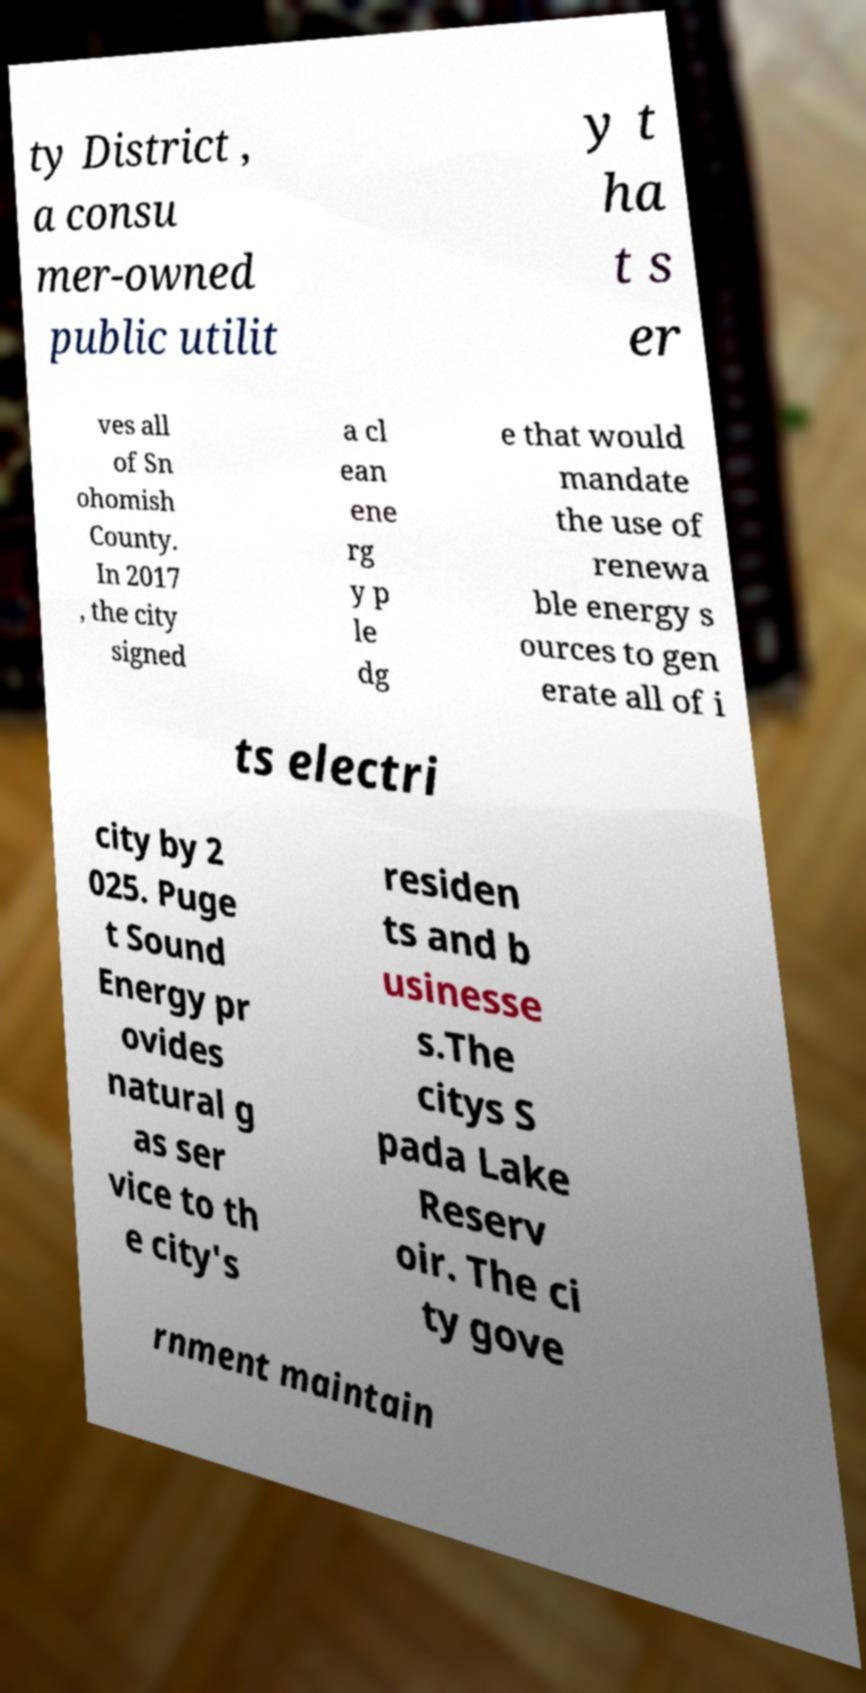I need the written content from this picture converted into text. Can you do that? ty District , a consu mer-owned public utilit y t ha t s er ves all of Sn ohomish County. In 2017 , the city signed a cl ean ene rg y p le dg e that would mandate the use of renewa ble energy s ources to gen erate all of i ts electri city by 2 025. Puge t Sound Energy pr ovides natural g as ser vice to th e city's residen ts and b usinesse s.The citys S pada Lake Reserv oir. The ci ty gove rnment maintain 